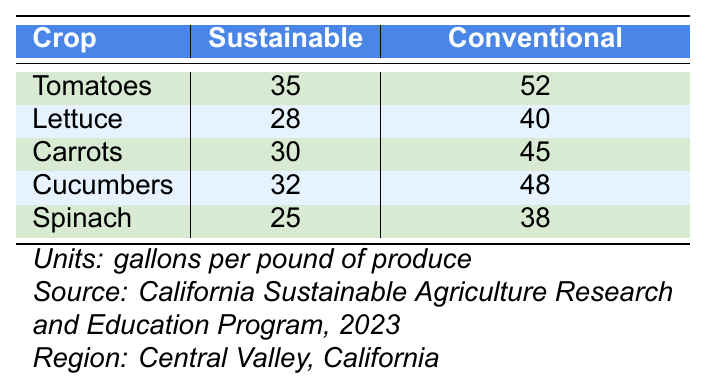What is the water usage for sustainable farming of tomatoes? According to the table, the water usage for sustainable farming of tomatoes is listed under the "Sustainable" column next to "Tomatoes," which indicates a usage of 35 gallons per pound of produce.
Answer: 35 Which crop has the highest water usage in conventional farming? By comparing the values in the "Conventional" column for all crops, it is found that tomatoes have the highest water usage at 52 gallons per pound of produce.
Answer: Tomatoes What is the difference in water usage between sustainable and conventional farming for carrots? The water usage for sustainable farming of carrots is 30 and for conventional is 45. The difference is 45 - 30 = 15 gallons per pound of produce.
Answer: 15 Is the water usage for sustainable farming lower than 30 gallons per pound for any crop? Checking the sustainable water usage values, spinach is used at 25 gallons per pound of produce, which is indeed lower than 30.
Answer: Yes Which farming method uses less water for cucumbers and by how much? For cucumbers, sustainable farming uses 32 gallons and conventional uses 48 gallons. The sustainable method uses 48 - 32 = 16 gallons less.
Answer: 16 What is the average water usage for conventional farming across all crops? First, add the conventional water usage values: 52 + 40 + 45 + 48 + 38 = 223. Then, divide by the number of crops (5). The average is 223 / 5 = 44.6 gallons per pound of produce.
Answer: 44.6 Are there any crops for which the water usage in sustainable farming is higher than in conventional farming? By checking each crop, all sustainable values are less than their respective conventional values. Thus, there are no cases where sustainable farming uses more water.
Answer: No Which crop has the least water usage in sustainable farming? Looking at the sustainable values, spinach has the lowest water usage at 25 gallons per pound of produce when compared to other crops.
Answer: Spinach If a hotel serves 500 pounds of conventional tomatoes, how much water is used? The water usage for conventional tomatoes is 52 gallons per pound. Therefore, for 500 pounds, it would be 500 * 52 = 26,000 gallons.
Answer: 26,000 What is the total water usage for sustainable farming for all crops combined? To find this, sum the sustainable values: 35 (tomatoes) + 28 (lettuce) + 30 (carrots) + 32 (cucumbers) + 25 (spinach) = 150 gallons per pound.
Answer: 150 